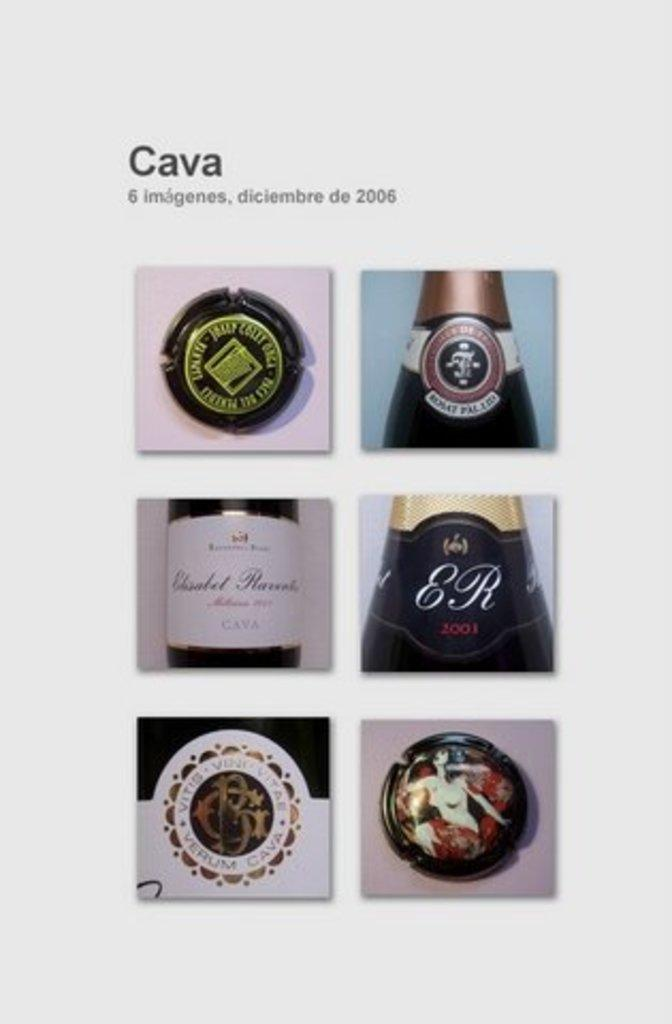<image>
Offer a succinct explanation of the picture presented. Collage of photos for a wine bottle that says ER on it. 